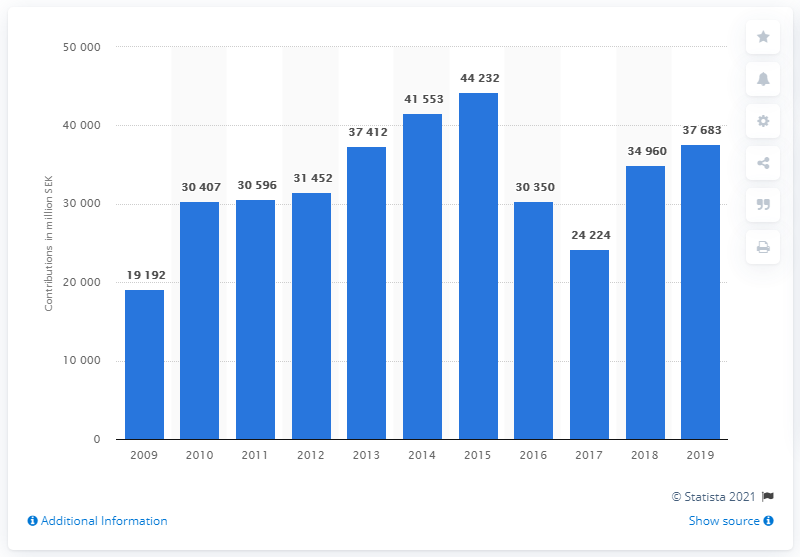Indicate a few pertinent items in this graphic. Sweden's contributions to the European Union budget began to decline in 2015. In 2019, Sweden's contribution to the European Union budget was 376,833. 